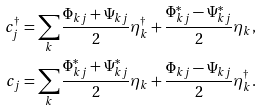<formula> <loc_0><loc_0><loc_500><loc_500>c _ { j } ^ { \dagger } = \sum _ { k } \frac { \Phi _ { k j } + \Psi _ { k j } } { 2 } \eta _ { k } ^ { \dagger } + \frac { \Phi _ { k j } ^ { * } - \Psi _ { k j } ^ { * } } { 2 } \eta _ { k } , \\ c _ { j } = \sum _ { k } \frac { \Phi _ { k j } ^ { * } + \Psi _ { k j } ^ { * } } { 2 } \eta _ { k } + \frac { \Phi _ { k j } - \Psi _ { k j } } { 2 } \eta _ { k } ^ { \dagger } .</formula> 